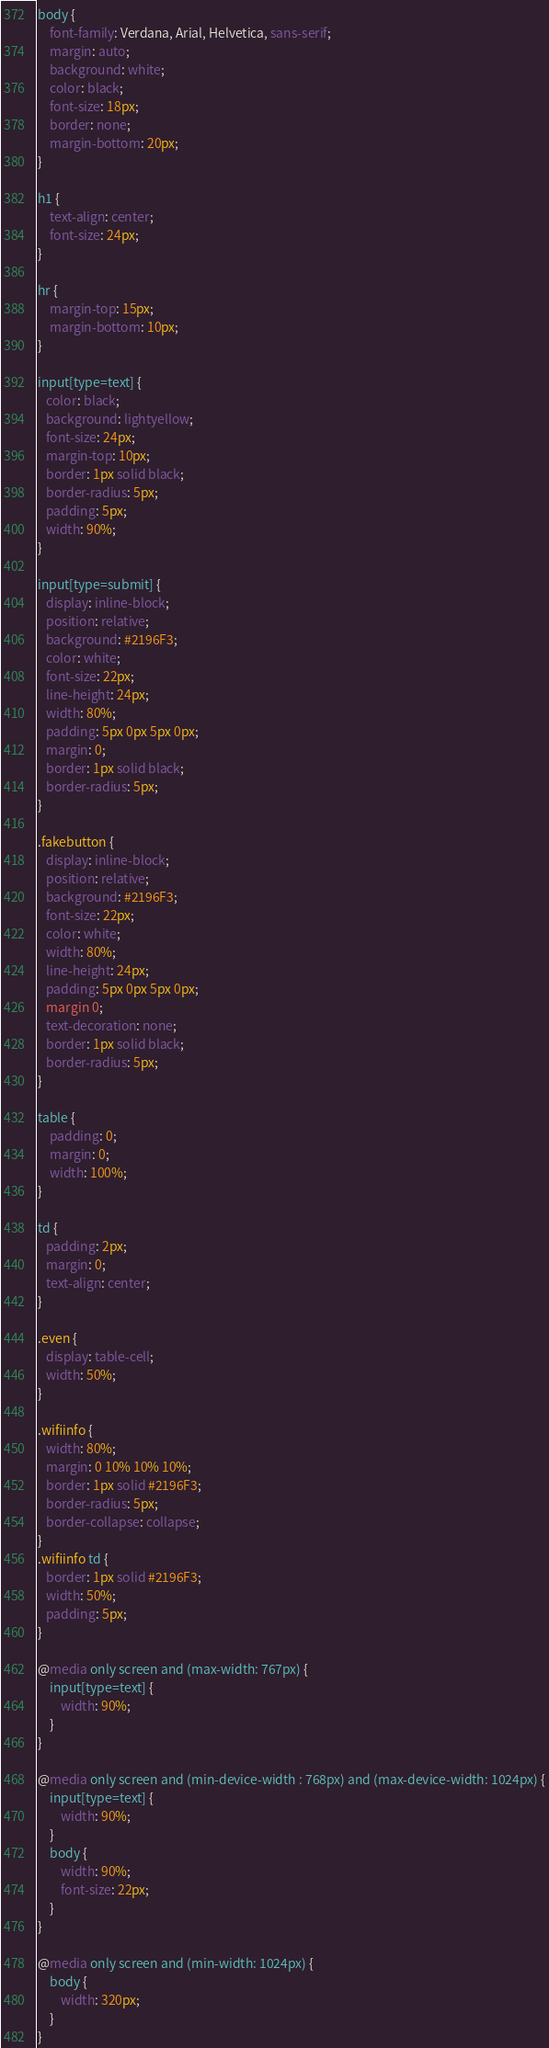Convert code to text. <code><loc_0><loc_0><loc_500><loc_500><_CSS_>body {
    font-family: Verdana, Arial, Helvetica, sans-serif;
    margin: auto;
    background: white;
    color: black;
    font-size: 18px;
    border: none;
    margin-bottom: 20px;
}

h1 {
    text-align: center;
    font-size: 24px;
}

hr {
    margin-top: 15px;
    margin-bottom: 10px;
}

input[type=text] {
   color: black;
   background: lightyellow;
   font-size: 24px;
   margin-top: 10px;
   border: 1px solid black;
   border-radius: 5px;
   padding: 5px;
   width: 90%;
}

input[type=submit] {
   display: inline-block;
   position: relative;
   background: #2196F3;
   color: white;
   font-size: 22px;
   line-height: 24px;
   width: 80%;
   padding: 5px 0px 5px 0px;
   margin: 0;
   border: 1px solid black;
   border-radius: 5px;
}

.fakebutton {
   display: inline-block;
   position: relative;
   background: #2196F3;
   font-size: 22px;
   color: white;
   width: 80%;
   line-height: 24px;
   padding: 5px 0px 5px 0px;
   margin 0;
   text-decoration: none;
   border: 1px solid black;
   border-radius: 5px;
}

table {
    padding: 0;
    margin: 0;
    width: 100%;
}

td {
   padding: 2px;
   margin: 0;
   text-align: center;
}

.even {
   display: table-cell;
   width: 50%;
}

.wifiinfo {
   width: 80%;
   margin: 0 10% 10% 10%;
   border: 1px solid #2196F3;
   border-radius: 5px;
   border-collapse: collapse;
}
.wifiinfo td {
   border: 1px solid #2196F3;
   width: 50%;
   padding: 5px;
}

@media only screen and (max-width: 767px) {
    input[type=text] {
        width: 90%;
    }
}

@media only screen and (min-device-width : 768px) and (max-device-width: 1024px) {
    input[type=text] {
        width: 90%;
    }
    body {
        width: 90%;
        font-size: 22px;
    }
}

@media only screen and (min-width: 1024px) {
    body {
        width: 320px;
    }
}

</code> 